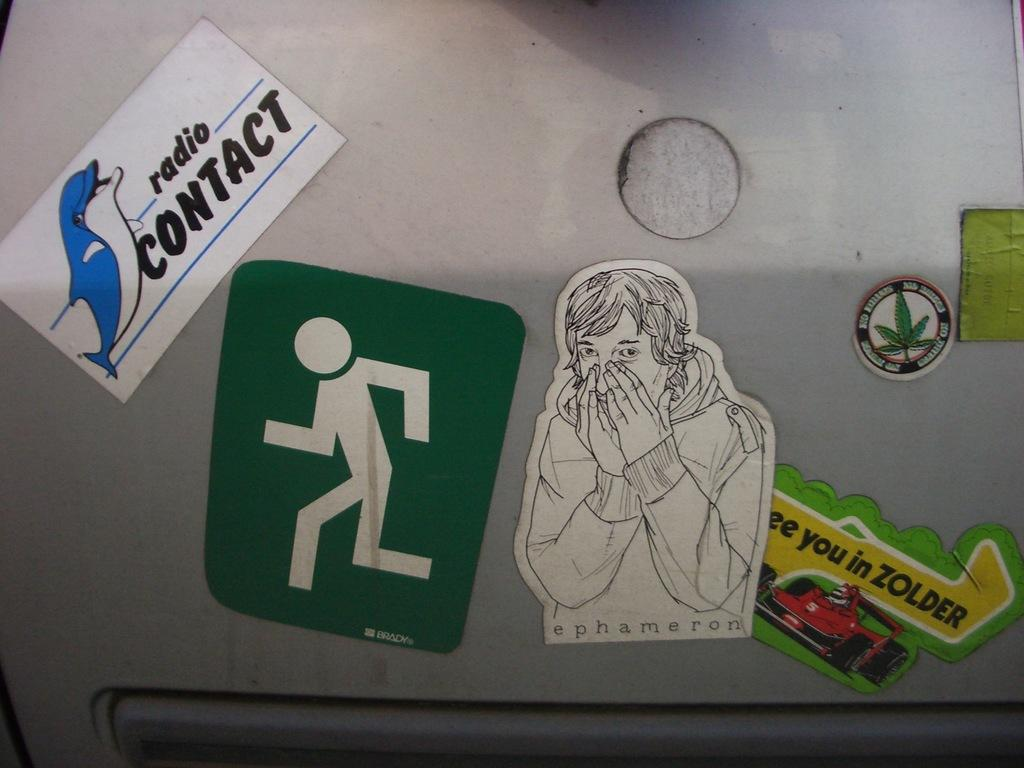What is on the wall in the image? There are stickers on the wall in the image. What type of education is being taught in the image? There is no indication of any teaching or education in the image; it only shows stickers on the wall. 